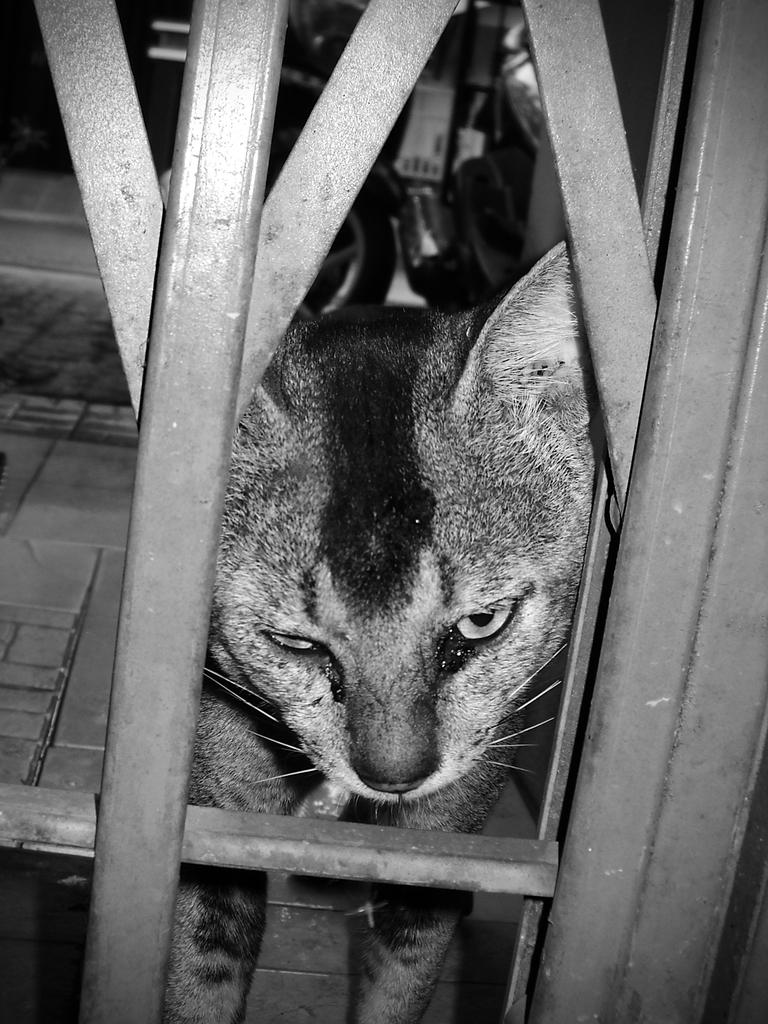What structure can be seen in the image? There is a gate in the image. How much of the gate is visible? A part of the gate is visible in the image. What animal is present near the gate? A cat is looking out from the gate. What type of coal is being used to start the engine in the image? There is no engine or coal present in the image; it features a gate with a cat looking out from it. 